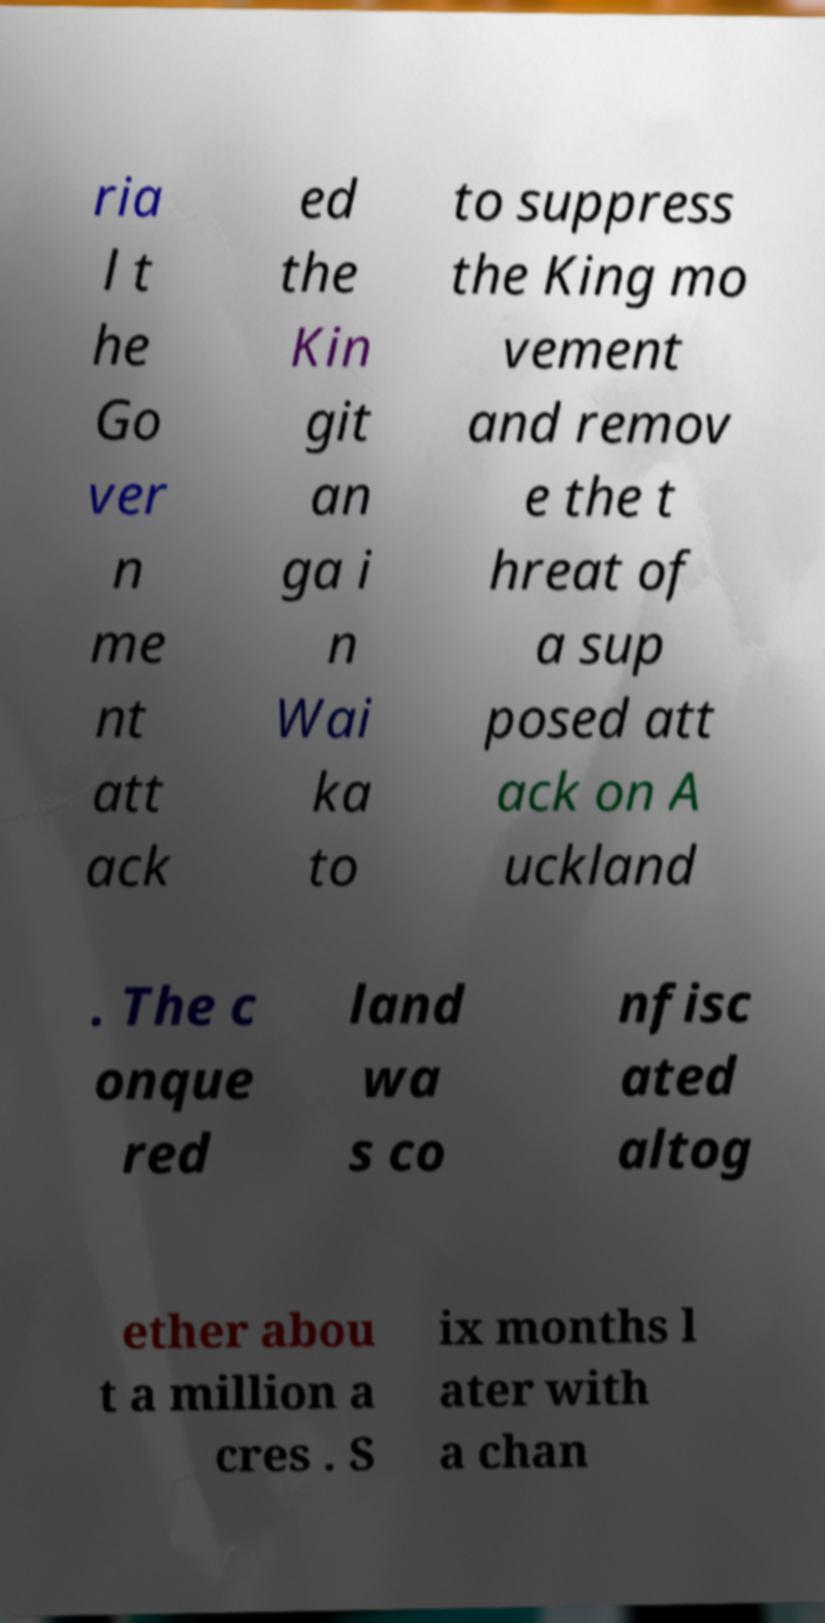Please identify and transcribe the text found in this image. ria l t he Go ver n me nt att ack ed the Kin git an ga i n Wai ka to to suppress the King mo vement and remov e the t hreat of a sup posed att ack on A uckland . The c onque red land wa s co nfisc ated altog ether abou t a million a cres . S ix months l ater with a chan 